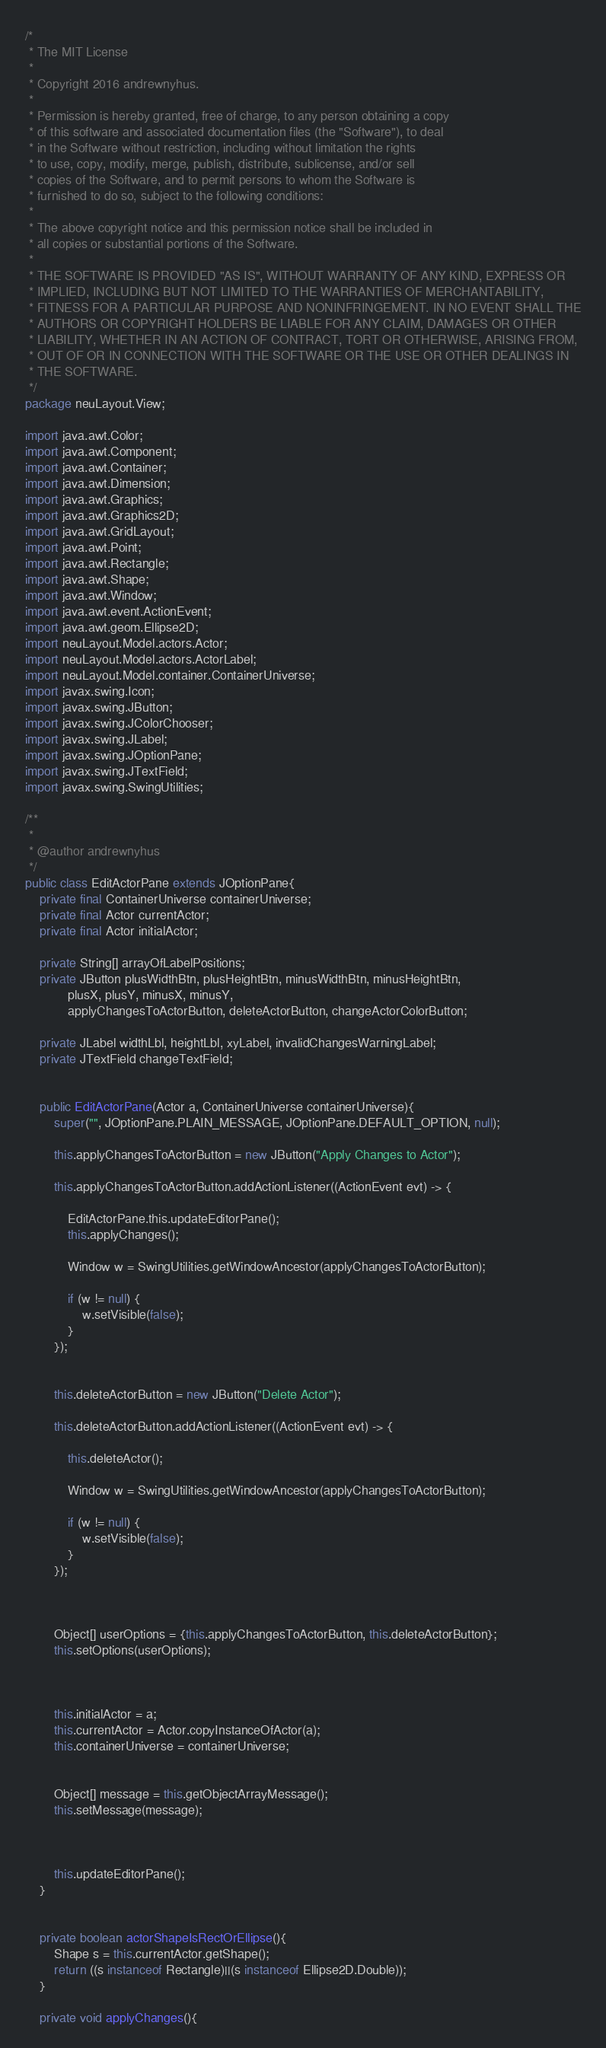Convert code to text. <code><loc_0><loc_0><loc_500><loc_500><_Java_>/*
 * The MIT License
 *
 * Copyright 2016 andrewnyhus.
 *
 * Permission is hereby granted, free of charge, to any person obtaining a copy
 * of this software and associated documentation files (the "Software"), to deal
 * in the Software without restriction, including without limitation the rights
 * to use, copy, modify, merge, publish, distribute, sublicense, and/or sell
 * copies of the Software, and to permit persons to whom the Software is
 * furnished to do so, subject to the following conditions:
 *
 * The above copyright notice and this permission notice shall be included in
 * all copies or substantial portions of the Software.
 *
 * THE SOFTWARE IS PROVIDED "AS IS", WITHOUT WARRANTY OF ANY KIND, EXPRESS OR
 * IMPLIED, INCLUDING BUT NOT LIMITED TO THE WARRANTIES OF MERCHANTABILITY,
 * FITNESS FOR A PARTICULAR PURPOSE AND NONINFRINGEMENT. IN NO EVENT SHALL THE
 * AUTHORS OR COPYRIGHT HOLDERS BE LIABLE FOR ANY CLAIM, DAMAGES OR OTHER
 * LIABILITY, WHETHER IN AN ACTION OF CONTRACT, TORT OR OTHERWISE, ARISING FROM,
 * OUT OF OR IN CONNECTION WITH THE SOFTWARE OR THE USE OR OTHER DEALINGS IN
 * THE SOFTWARE.
 */
package neuLayout.View;

import java.awt.Color;
import java.awt.Component;
import java.awt.Container;
import java.awt.Dimension;
import java.awt.Graphics;
import java.awt.Graphics2D;
import java.awt.GridLayout;
import java.awt.Point;
import java.awt.Rectangle;
import java.awt.Shape;
import java.awt.Window;
import java.awt.event.ActionEvent;
import java.awt.geom.Ellipse2D;
import neuLayout.Model.actors.Actor;
import neuLayout.Model.actors.ActorLabel;
import neuLayout.Model.container.ContainerUniverse;
import javax.swing.Icon;
import javax.swing.JButton;
import javax.swing.JColorChooser;
import javax.swing.JLabel;
import javax.swing.JOptionPane;
import javax.swing.JTextField;
import javax.swing.SwingUtilities;

/**
 *
 * @author andrewnyhus
 */
public class EditActorPane extends JOptionPane{
    private final ContainerUniverse containerUniverse;
    private final Actor currentActor;
    private final Actor initialActor;
    
    private String[] arrayOfLabelPositions;
    private JButton plusWidthBtn, plusHeightBtn, minusWidthBtn, minusHeightBtn,
            plusX, plusY, minusX, minusY,
            applyChangesToActorButton, deleteActorButton, changeActorColorButton;
    
    private JLabel widthLbl, heightLbl, xyLabel, invalidChangesWarningLabel;
    private JTextField changeTextField;

    
    public EditActorPane(Actor a, ContainerUniverse containerUniverse){
        super("", JOptionPane.PLAIN_MESSAGE, JOptionPane.DEFAULT_OPTION, null);

        this.applyChangesToActorButton = new JButton("Apply Changes to Actor");
        
        this.applyChangesToActorButton.addActionListener((ActionEvent evt) -> {
        
            EditActorPane.this.updateEditorPane();
            this.applyChanges();
            
            Window w = SwingUtilities.getWindowAncestor(applyChangesToActorButton);

            if (w != null) {
                w.setVisible(false);
            }
        });  
        
        
        this.deleteActorButton = new JButton("Delete Actor");
        
        this.deleteActorButton.addActionListener((ActionEvent evt) -> {
            
            this.deleteActor();
            
            Window w = SwingUtilities.getWindowAncestor(applyChangesToActorButton);

            if (w != null) {
                w.setVisible(false);
            }
        });  
        
                
        
        Object[] userOptions = {this.applyChangesToActorButton, this.deleteActorButton};
        this.setOptions(userOptions);
        
        
        
        this.initialActor = a;
        this.currentActor = Actor.copyInstanceOfActor(a);
        this.containerUniverse = containerUniverse;
        
        
        Object[] message = this.getObjectArrayMessage();
        this.setMessage(message);
        
     

        this.updateEditorPane();
    }
    

    private boolean actorShapeIsRectOrEllipse(){
        Shape s = this.currentActor.getShape();
        return ((s instanceof Rectangle)||(s instanceof Ellipse2D.Double));
    }
    
    private void applyChanges(){</code> 